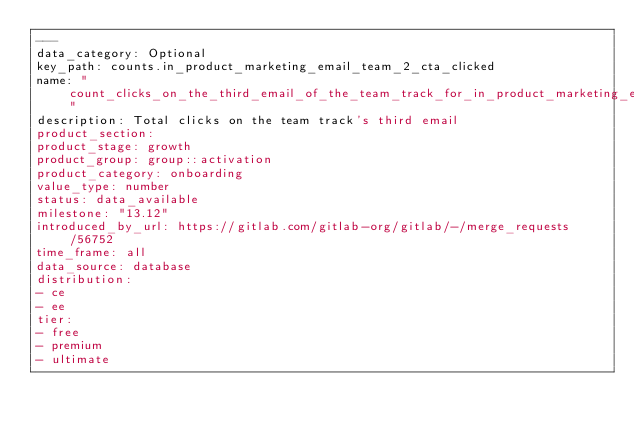Convert code to text. <code><loc_0><loc_0><loc_500><loc_500><_YAML_>---
data_category: Optional
key_path: counts.in_product_marketing_email_team_2_cta_clicked
name: "count_clicks_on_the_third_email_of_the_team_track_for_in_product_marketing_emails"
description: Total clicks on the team track's third email
product_section:
product_stage: growth
product_group: group::activation
product_category: onboarding
value_type: number
status: data_available
milestone: "13.12"
introduced_by_url: https://gitlab.com/gitlab-org/gitlab/-/merge_requests/56752
time_frame: all
data_source: database
distribution:
- ce
- ee
tier:
- free
- premium
- ultimate
</code> 